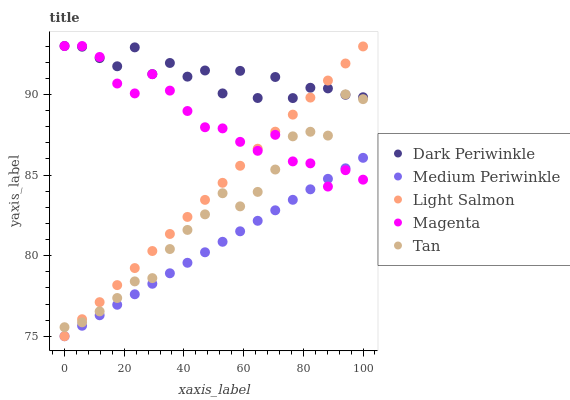Does Medium Periwinkle have the minimum area under the curve?
Answer yes or no. Yes. Does Dark Periwinkle have the maximum area under the curve?
Answer yes or no. Yes. Does Light Salmon have the minimum area under the curve?
Answer yes or no. No. Does Light Salmon have the maximum area under the curve?
Answer yes or no. No. Is Light Salmon the smoothest?
Answer yes or no. Yes. Is Dark Periwinkle the roughest?
Answer yes or no. Yes. Is Medium Periwinkle the smoothest?
Answer yes or no. No. Is Medium Periwinkle the roughest?
Answer yes or no. No. Does Light Salmon have the lowest value?
Answer yes or no. Yes. Does Dark Periwinkle have the lowest value?
Answer yes or no. No. Does Magenta have the highest value?
Answer yes or no. Yes. Does Light Salmon have the highest value?
Answer yes or no. No. Is Medium Periwinkle less than Dark Periwinkle?
Answer yes or no. Yes. Is Tan greater than Medium Periwinkle?
Answer yes or no. Yes. Does Magenta intersect Light Salmon?
Answer yes or no. Yes. Is Magenta less than Light Salmon?
Answer yes or no. No. Is Magenta greater than Light Salmon?
Answer yes or no. No. Does Medium Periwinkle intersect Dark Periwinkle?
Answer yes or no. No. 